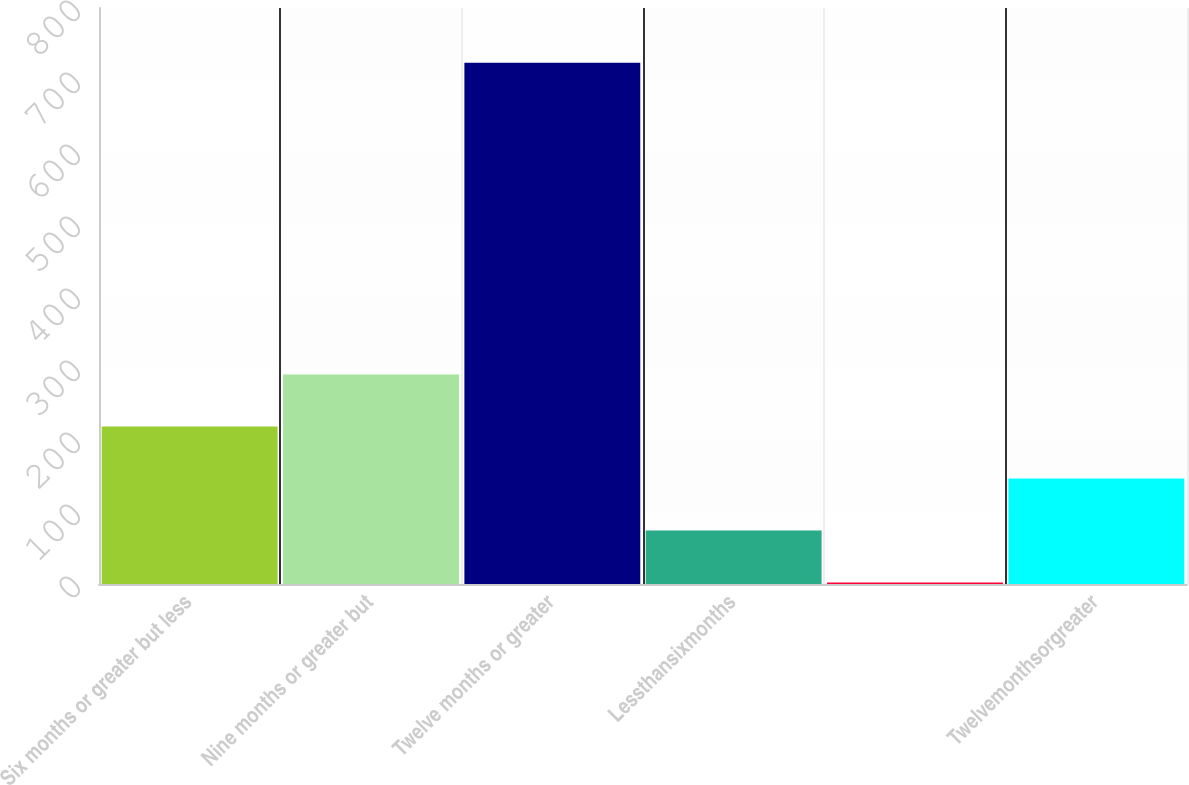Convert chart. <chart><loc_0><loc_0><loc_500><loc_500><bar_chart><fcel>Six months or greater but less<fcel>Nine months or greater but<fcel>Twelve months or greater<fcel>Lessthansixmonths<fcel>Unnamed: 4<fcel>Twelvemonthsorgreater<nl><fcel>218.6<fcel>290.8<fcel>724<fcel>74.2<fcel>2<fcel>146.4<nl></chart> 